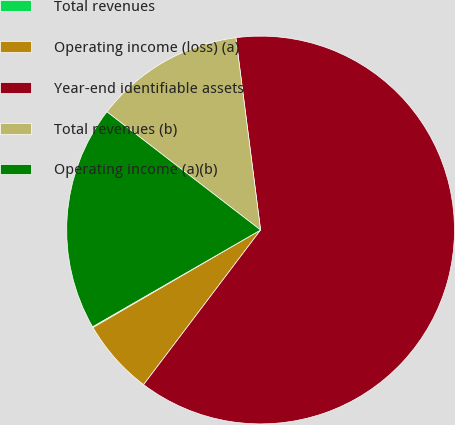<chart> <loc_0><loc_0><loc_500><loc_500><pie_chart><fcel>Total revenues<fcel>Operating income (loss) (a)<fcel>Year-end identifiable assets<fcel>Total revenues (b)<fcel>Operating income (a)(b)<nl><fcel>0.08%<fcel>6.3%<fcel>62.34%<fcel>12.53%<fcel>18.75%<nl></chart> 